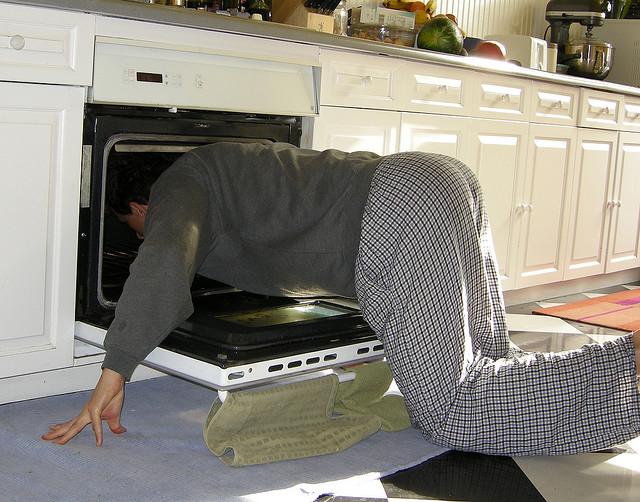Is this person a slob?
Keep it brief. No. What pattern are his pants?
Be succinct. Plaid. Is the man trying to commit suicide?
Keep it brief. No. 